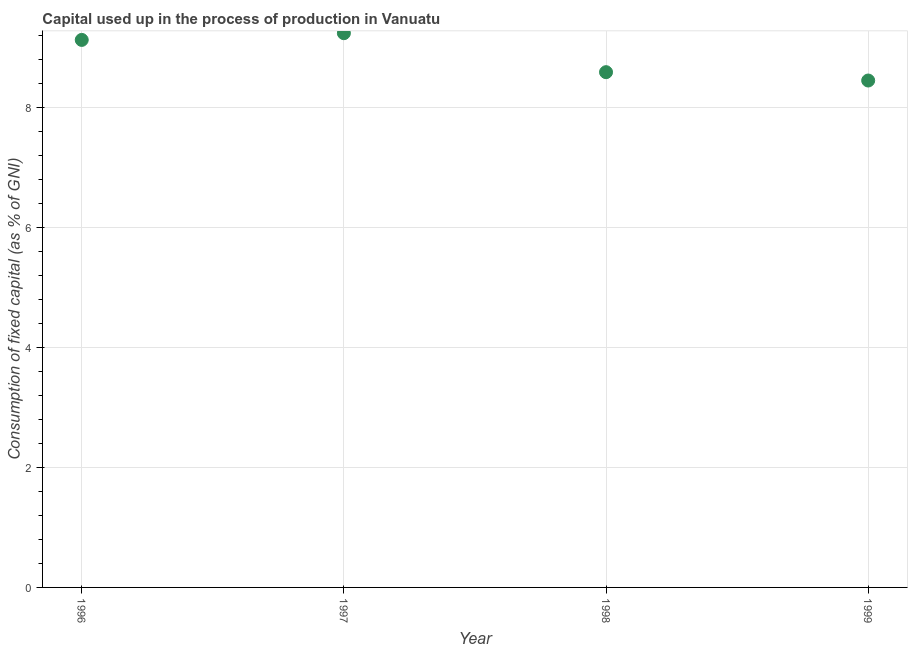What is the consumption of fixed capital in 1999?
Your response must be concise. 8.44. Across all years, what is the maximum consumption of fixed capital?
Your response must be concise. 9.23. Across all years, what is the minimum consumption of fixed capital?
Provide a succinct answer. 8.44. In which year was the consumption of fixed capital maximum?
Offer a very short reply. 1997. What is the sum of the consumption of fixed capital?
Ensure brevity in your answer.  35.38. What is the difference between the consumption of fixed capital in 1996 and 1998?
Your answer should be very brief. 0.54. What is the average consumption of fixed capital per year?
Your response must be concise. 8.85. What is the median consumption of fixed capital?
Provide a succinct answer. 8.85. In how many years, is the consumption of fixed capital greater than 6 %?
Keep it short and to the point. 4. What is the ratio of the consumption of fixed capital in 1998 to that in 1999?
Your answer should be compact. 1.02. What is the difference between the highest and the second highest consumption of fixed capital?
Ensure brevity in your answer.  0.11. Is the sum of the consumption of fixed capital in 1996 and 1999 greater than the maximum consumption of fixed capital across all years?
Give a very brief answer. Yes. What is the difference between the highest and the lowest consumption of fixed capital?
Your answer should be very brief. 0.79. In how many years, is the consumption of fixed capital greater than the average consumption of fixed capital taken over all years?
Give a very brief answer. 2. Does the consumption of fixed capital monotonically increase over the years?
Provide a succinct answer. No. How many years are there in the graph?
Offer a very short reply. 4. What is the difference between two consecutive major ticks on the Y-axis?
Keep it short and to the point. 2. Are the values on the major ticks of Y-axis written in scientific E-notation?
Your answer should be very brief. No. Does the graph contain any zero values?
Your answer should be compact. No. Does the graph contain grids?
Offer a very short reply. Yes. What is the title of the graph?
Make the answer very short. Capital used up in the process of production in Vanuatu. What is the label or title of the Y-axis?
Ensure brevity in your answer.  Consumption of fixed capital (as % of GNI). What is the Consumption of fixed capital (as % of GNI) in 1996?
Your response must be concise. 9.12. What is the Consumption of fixed capital (as % of GNI) in 1997?
Your answer should be compact. 9.23. What is the Consumption of fixed capital (as % of GNI) in 1998?
Your answer should be compact. 8.58. What is the Consumption of fixed capital (as % of GNI) in 1999?
Your answer should be very brief. 8.44. What is the difference between the Consumption of fixed capital (as % of GNI) in 1996 and 1997?
Your answer should be compact. -0.11. What is the difference between the Consumption of fixed capital (as % of GNI) in 1996 and 1998?
Offer a very short reply. 0.54. What is the difference between the Consumption of fixed capital (as % of GNI) in 1996 and 1999?
Your answer should be very brief. 0.68. What is the difference between the Consumption of fixed capital (as % of GNI) in 1997 and 1998?
Ensure brevity in your answer.  0.65. What is the difference between the Consumption of fixed capital (as % of GNI) in 1997 and 1999?
Your response must be concise. 0.79. What is the difference between the Consumption of fixed capital (as % of GNI) in 1998 and 1999?
Give a very brief answer. 0.14. What is the ratio of the Consumption of fixed capital (as % of GNI) in 1996 to that in 1998?
Offer a very short reply. 1.06. What is the ratio of the Consumption of fixed capital (as % of GNI) in 1996 to that in 1999?
Offer a terse response. 1.08. What is the ratio of the Consumption of fixed capital (as % of GNI) in 1997 to that in 1998?
Make the answer very short. 1.08. What is the ratio of the Consumption of fixed capital (as % of GNI) in 1997 to that in 1999?
Ensure brevity in your answer.  1.09. What is the ratio of the Consumption of fixed capital (as % of GNI) in 1998 to that in 1999?
Your answer should be very brief. 1.02. 